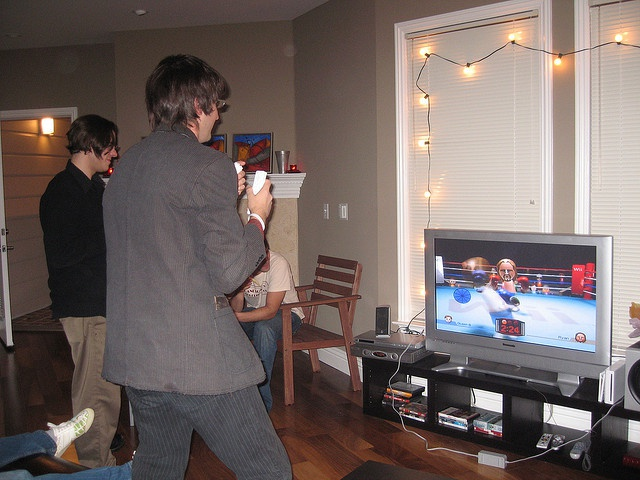Describe the objects in this image and their specific colors. I can see people in black and gray tones, tv in black, gray, lavender, and darkgray tones, people in black, gray, and maroon tones, chair in black, maroon, gray, and brown tones, and people in black, gray, brown, and tan tones in this image. 